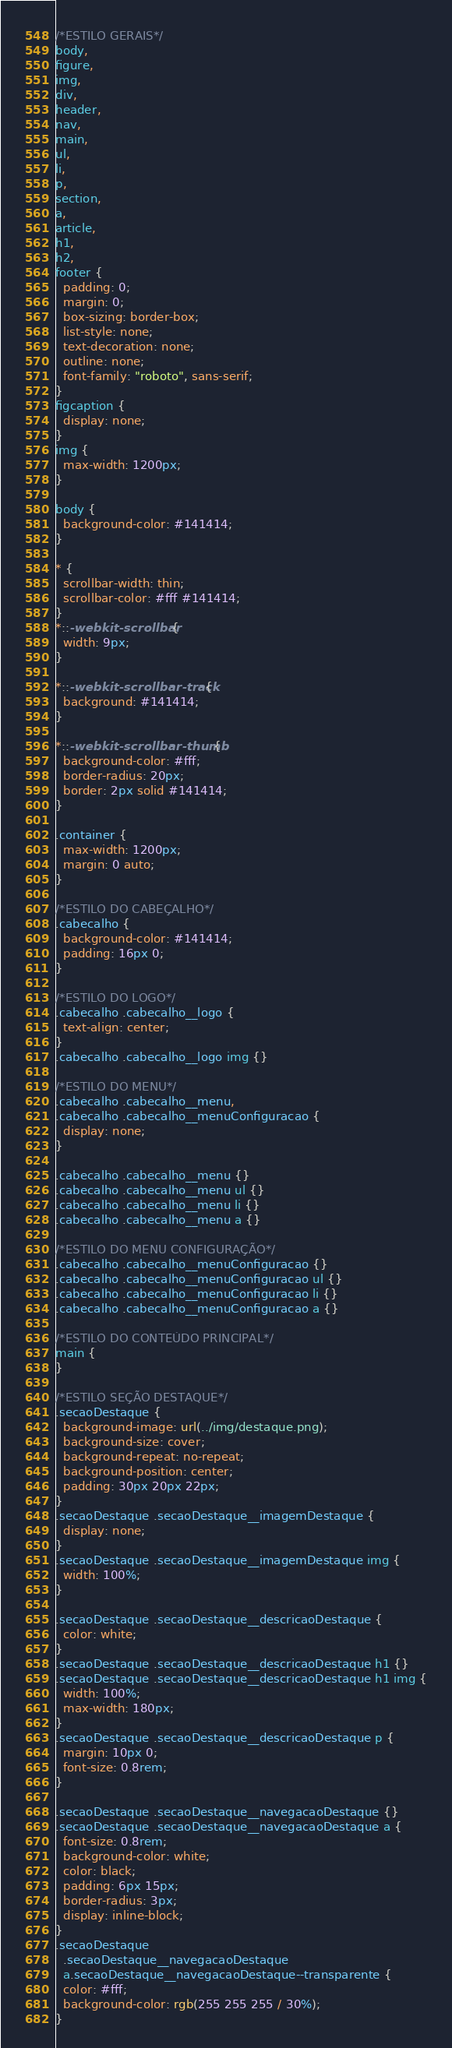Convert code to text. <code><loc_0><loc_0><loc_500><loc_500><_CSS_>/*ESTILO GERAIS*/
body,
figure,
img,
div,
header,
nav,
main,
ul,
li,
p,
section,
a,
article,
h1,
h2,
footer {
  padding: 0;
  margin: 0;
  box-sizing: border-box;
  list-style: none;
  text-decoration: none;
  outline: none;
  font-family: "roboto", sans-serif;
}
figcaption {
  display: none;
}
img {
  max-width: 1200px;
}

body {
  background-color: #141414;
}

* {
  scrollbar-width: thin;
  scrollbar-color: #fff #141414;
}
*::-webkit-scrollbar {
  width: 9px;
}

*::-webkit-scrollbar-track {
  background: #141414;
}

*::-webkit-scrollbar-thumb {
  background-color: #fff;
  border-radius: 20px;
  border: 2px solid #141414;
}

.container {
  max-width: 1200px;
  margin: 0 auto;
}

/*ESTILO DO CABEÇALHO*/
.cabecalho {
  background-color: #141414;
  padding: 16px 0;
}

/*ESTILO DO LOGO*/
.cabecalho .cabecalho__logo {
  text-align: center;
}
.cabecalho .cabecalho__logo img {}

/*ESTILO DO MENU*/
.cabecalho .cabecalho__menu,
.cabecalho .cabecalho__menuConfiguracao {
  display: none;
}

.cabecalho .cabecalho__menu {}
.cabecalho .cabecalho__menu ul {}
.cabecalho .cabecalho__menu li {}
.cabecalho .cabecalho__menu a {}

/*ESTILO DO MENU CONFIGURAÇÃO*/
.cabecalho .cabecalho__menuConfiguracao {}
.cabecalho .cabecalho__menuConfiguracao ul {}
.cabecalho .cabecalho__menuConfiguracao li {}
.cabecalho .cabecalho__menuConfiguracao a {}

/*ESTILO DO CONTEÚDO PRINCIPAL*/
main {
}

/*ESTILO SEÇÃO DESTAQUE*/
.secaoDestaque {
  background-image: url(../img/destaque.png);
  background-size: cover;
  background-repeat: no-repeat;
  background-position: center;
  padding: 30px 20px 22px;
}
.secaoDestaque .secaoDestaque__imagemDestaque {
  display: none;
}
.secaoDestaque .secaoDestaque__imagemDestaque img {
  width: 100%;
}

.secaoDestaque .secaoDestaque__descricaoDestaque {
  color: white;
}
.secaoDestaque .secaoDestaque__descricaoDestaque h1 {}
.secaoDestaque .secaoDestaque__descricaoDestaque h1 img {
  width: 100%;
  max-width: 180px;
}
.secaoDestaque .secaoDestaque__descricaoDestaque p {
  margin: 10px 0;
  font-size: 0.8rem;
}

.secaoDestaque .secaoDestaque__navegacaoDestaque {}
.secaoDestaque .secaoDestaque__navegacaoDestaque a {
  font-size: 0.8rem;
  background-color: white;
  color: black;
  padding: 6px 15px;
  border-radius: 3px;
  display: inline-block;
}
.secaoDestaque
  .secaoDestaque__navegacaoDestaque
  a.secaoDestaque__navegacaoDestaque--transparente {
  color: #fff;
  background-color: rgb(255 255 255 / 30%);
}</code> 